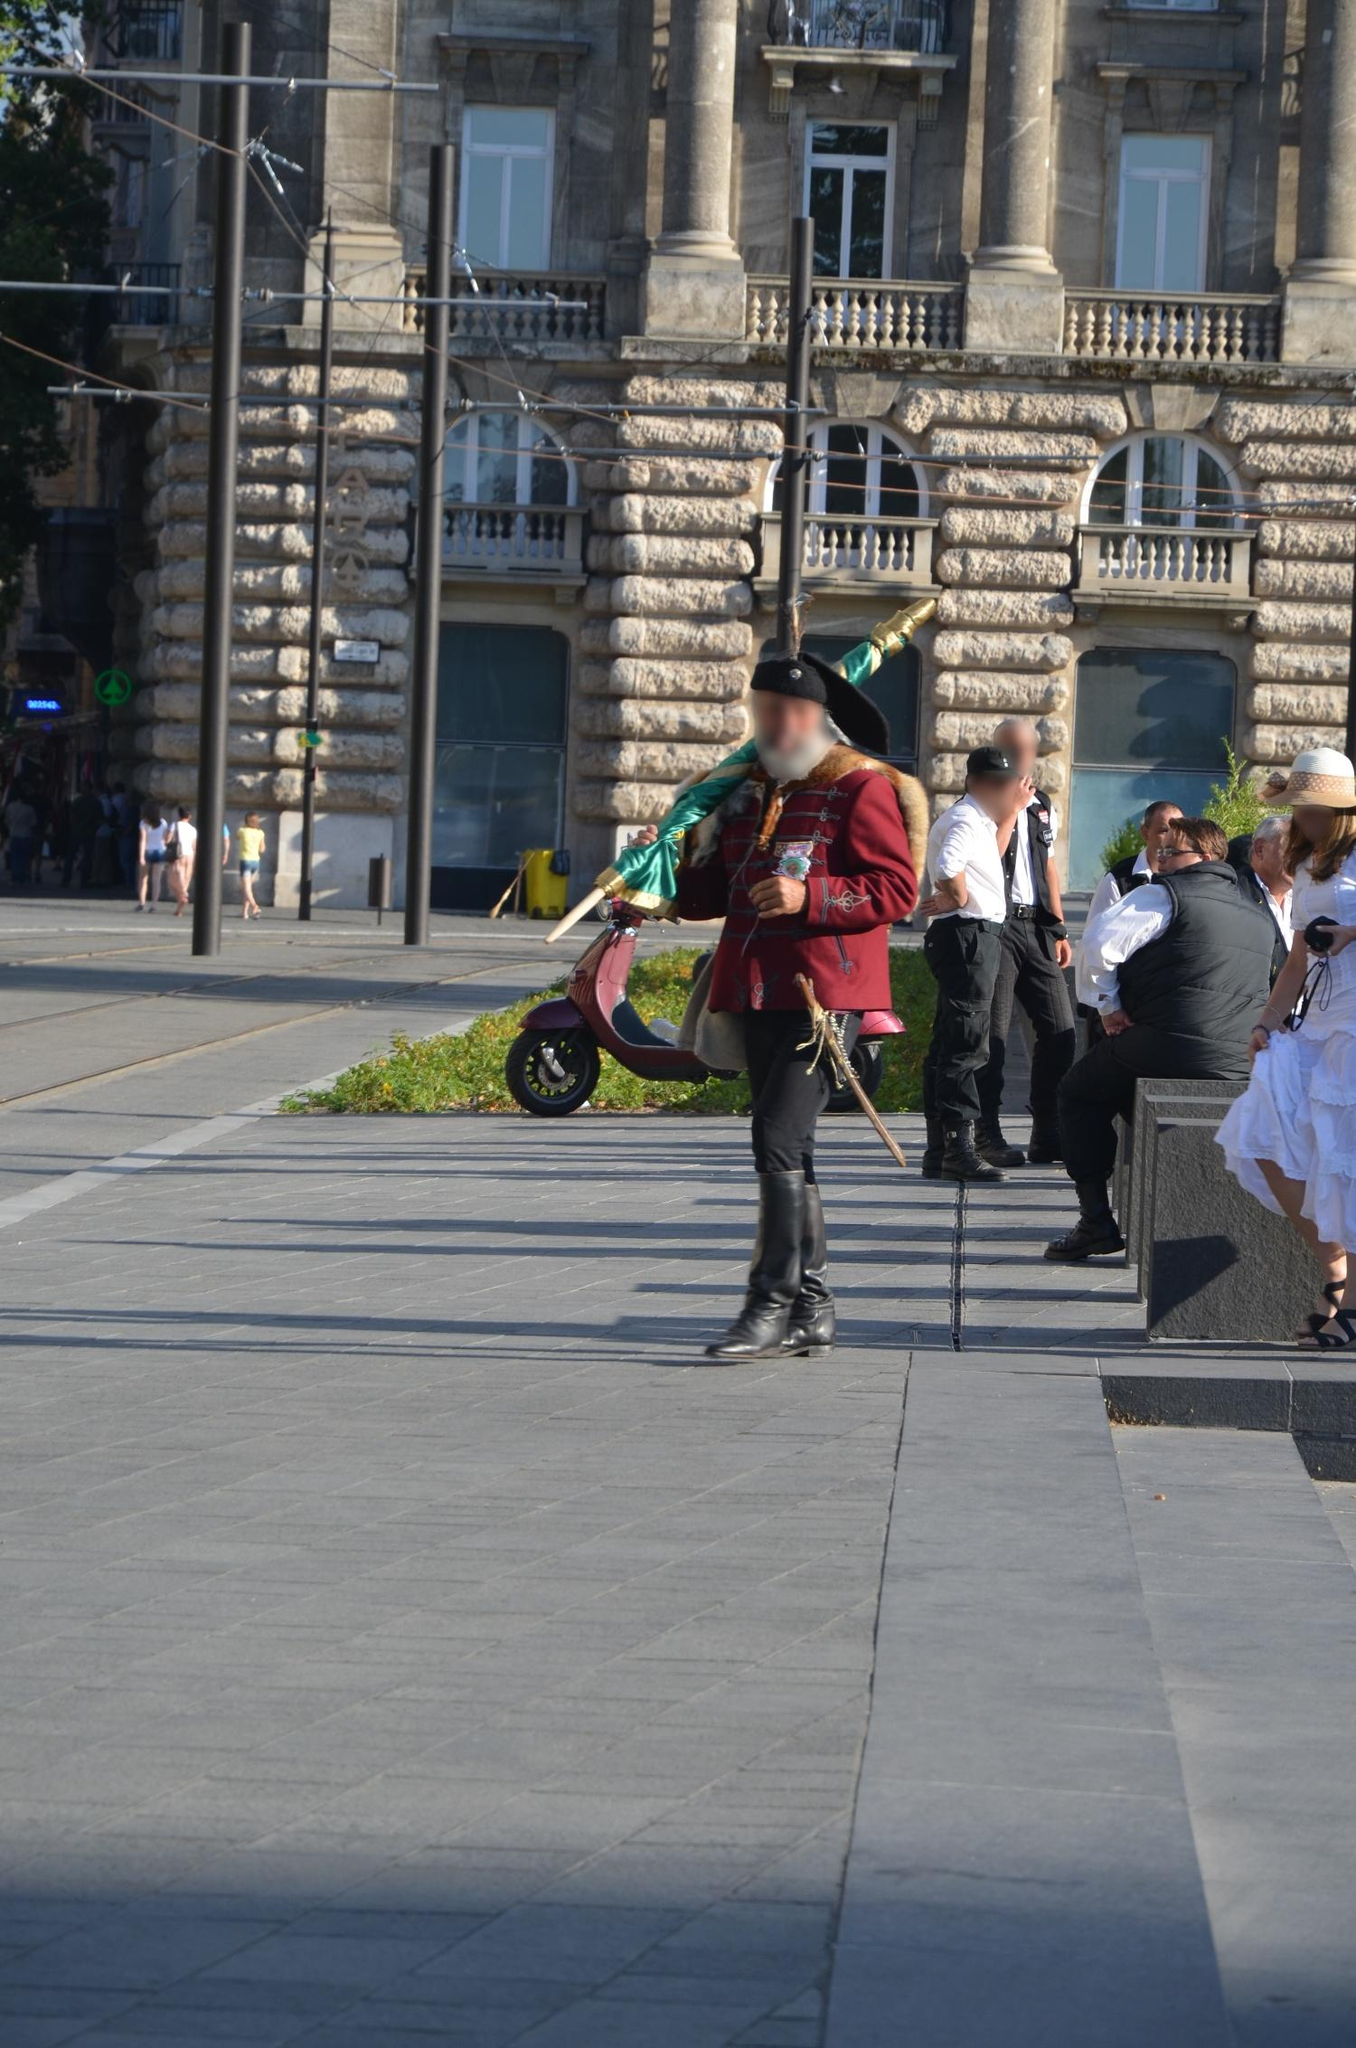What do you see happening in this image? The image captures a man in traditional Hungarian Hussar uniform, a sight that instantly transports you to the heart of Budapest, Hungary. The uniform is a vibrant display of history and culture, complete with a feathered hat that adds a touch of regality. In his hand, he holds a green flag, a symbol of pride and identity.

The man is walking on a sidewalk, his stride confident and purposeful. The low angle of the photo gives a sense of his imposing presence, as if he's a guardian of the city's heritage, walking towards the future while carrying the past with him.

The backdrop of the image is a bustling street in Budapest. A tram can be seen in the distance, a common mode of transport in the city, adding a touch of modernity to the scene. The building behind him is adorned with ornate decorations, a testament to the architectural grandeur that Budapest is known for.

As for the landmark, the information "sa_1736" seems to refer to an address in Senningerberg, Luxembourg[^1^]. However, without more specific details, it's challenging to determine the exact connection between the image and this address. The man's uniform and the architecture suggest the photo was taken in Hungary, not Luxembourg. It's possible that "sa_1736" could be a code or identifier used by the photographer or the organization that owns the image. 